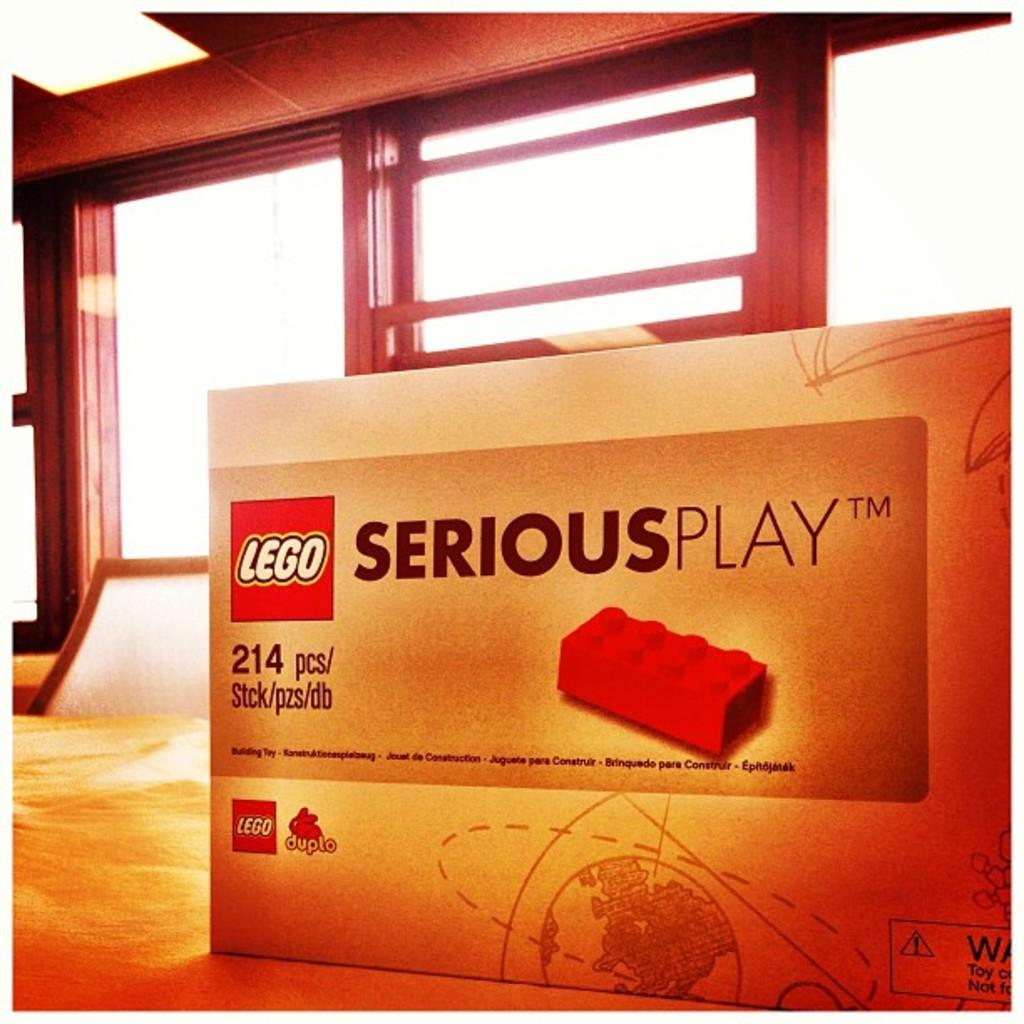What is the main object in the image? There is a board in the image. What can be seen in the middle of the image? There are windows in the middle of the image. What type of lead is being used to create the windows in the image? There is no indication of any lead being used in the image, and the windows are not being created in the image. 